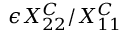Convert formula to latex. <formula><loc_0><loc_0><loc_500><loc_500>\epsilon X _ { 2 2 } ^ { C } / X _ { 1 1 } ^ { C }</formula> 